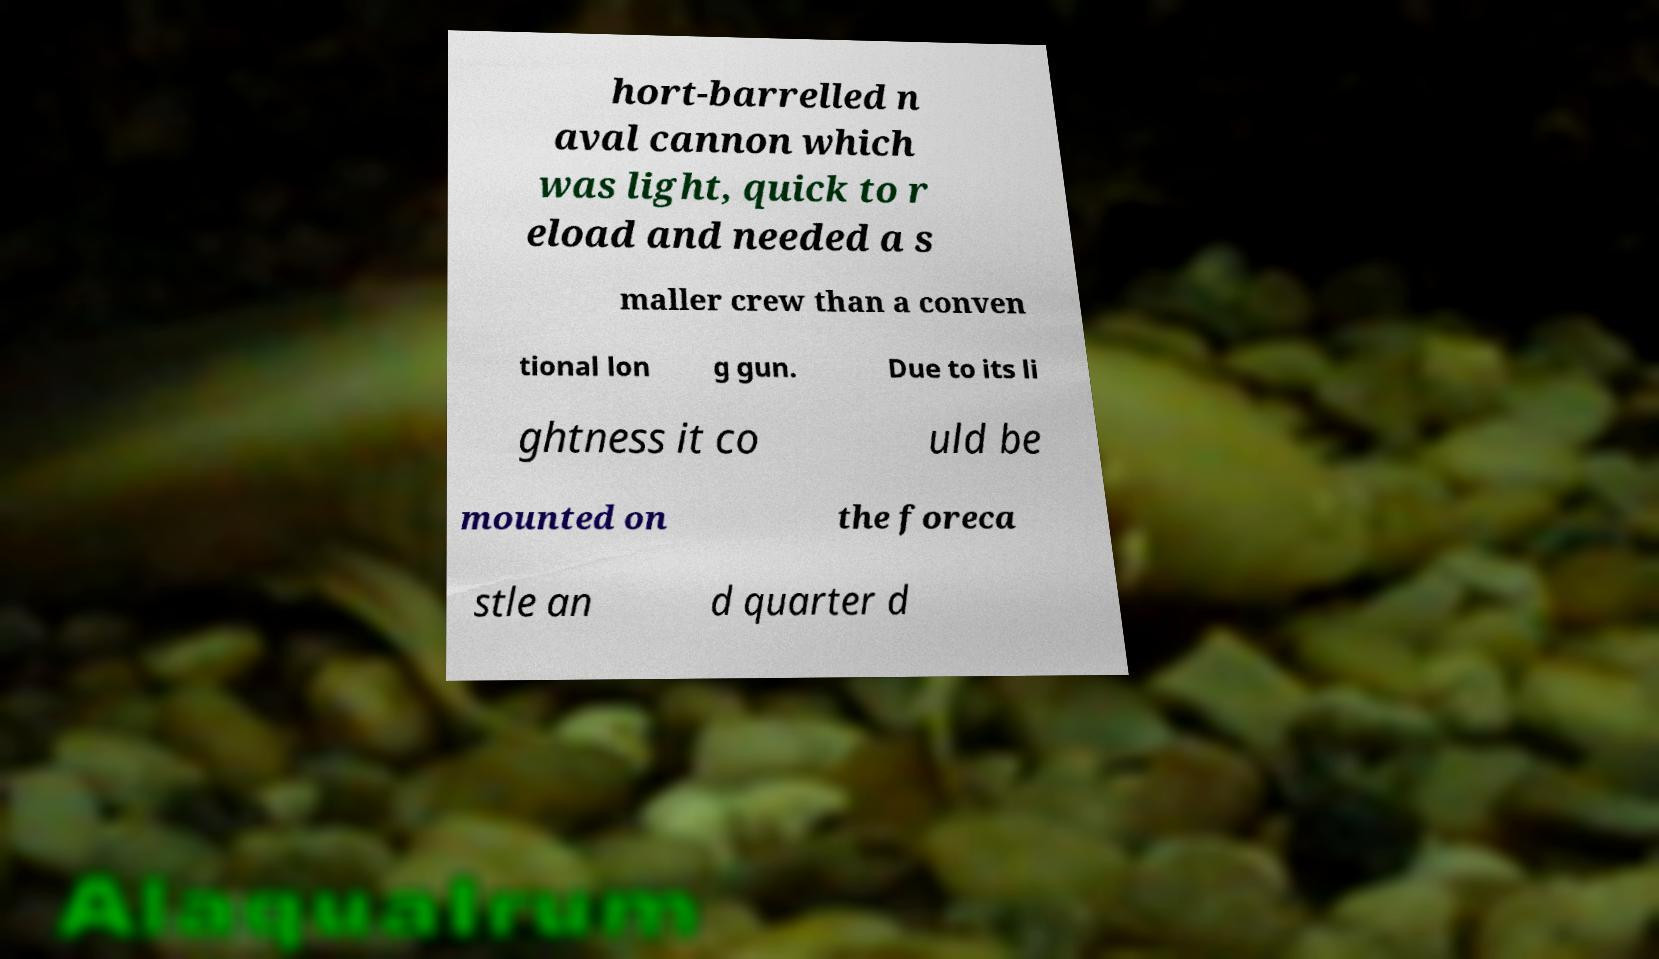Could you assist in decoding the text presented in this image and type it out clearly? hort-barrelled n aval cannon which was light, quick to r eload and needed a s maller crew than a conven tional lon g gun. Due to its li ghtness it co uld be mounted on the foreca stle an d quarter d 